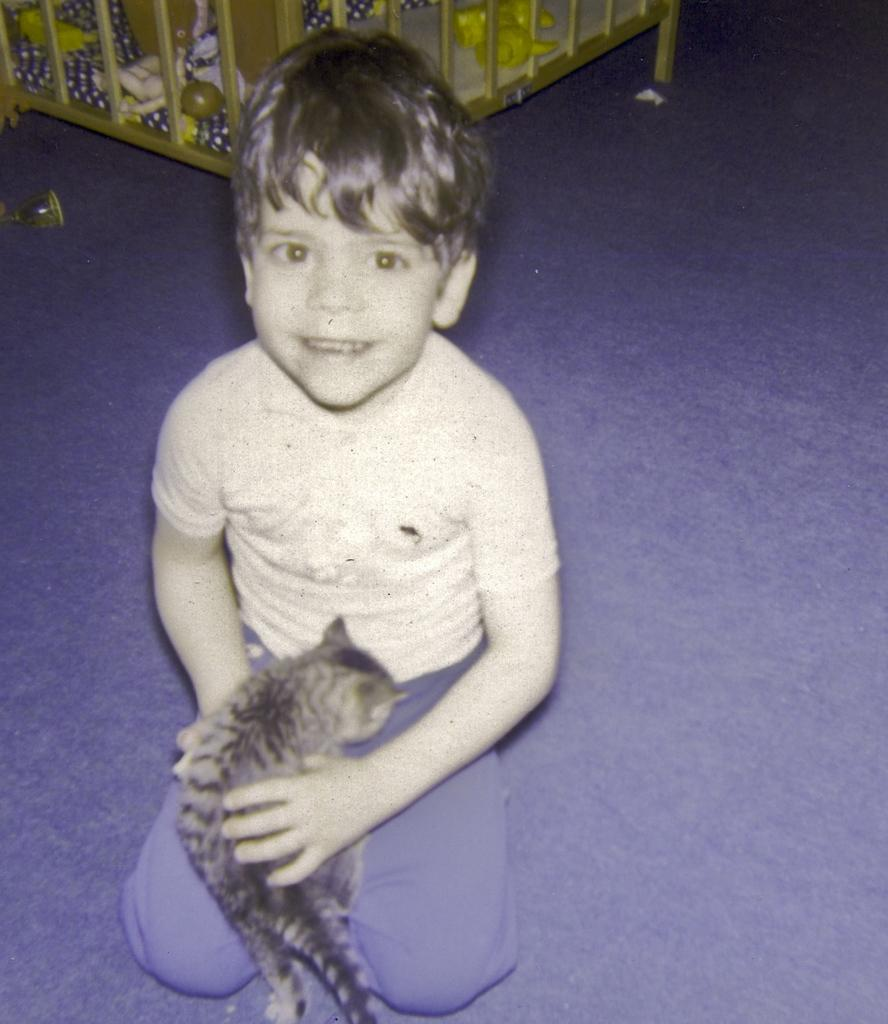What is the boy in the image doing? The boy is sitting on the floor. What is the boy holding in the image? The boy is holding a toy. What can be seen behind the boy in the image? There is a box behind the boy. What is inside the box? The box contains toys. What type of quill is the boy using to write on the box? There is no quill present in the image, and the boy is not writing on the box. 